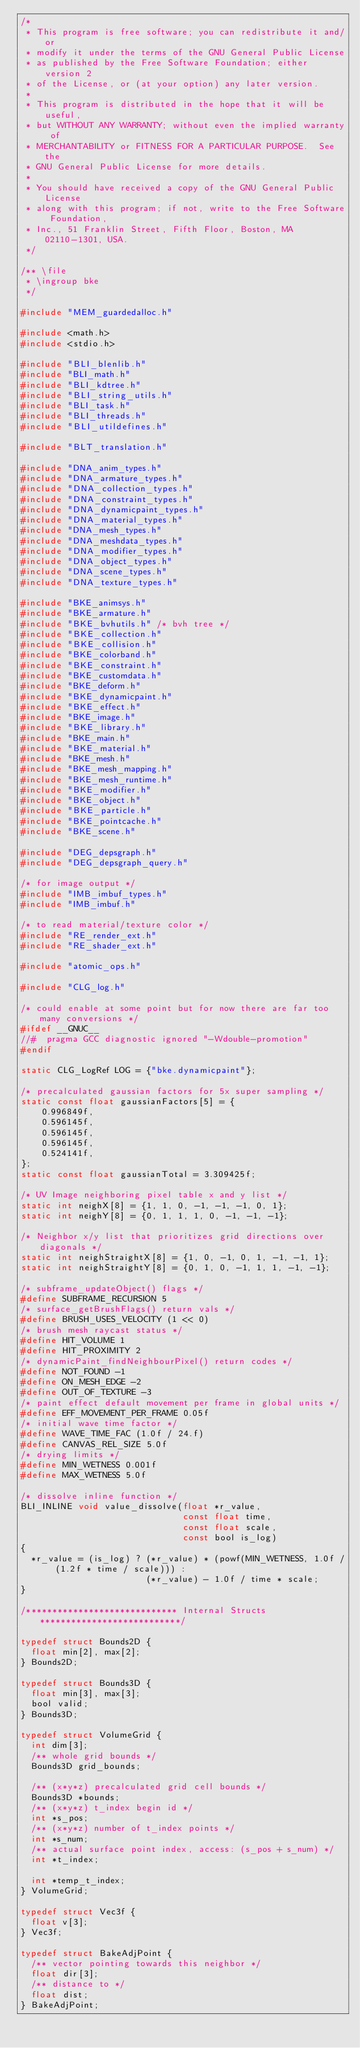<code> <loc_0><loc_0><loc_500><loc_500><_C_>/*
 * This program is free software; you can redistribute it and/or
 * modify it under the terms of the GNU General Public License
 * as published by the Free Software Foundation; either version 2
 * of the License, or (at your option) any later version.
 *
 * This program is distributed in the hope that it will be useful,
 * but WITHOUT ANY WARRANTY; without even the implied warranty of
 * MERCHANTABILITY or FITNESS FOR A PARTICULAR PURPOSE.  See the
 * GNU General Public License for more details.
 *
 * You should have received a copy of the GNU General Public License
 * along with this program; if not, write to the Free Software Foundation,
 * Inc., 51 Franklin Street, Fifth Floor, Boston, MA 02110-1301, USA.
 */

/** \file
 * \ingroup bke
 */

#include "MEM_guardedalloc.h"

#include <math.h>
#include <stdio.h>

#include "BLI_blenlib.h"
#include "BLI_math.h"
#include "BLI_kdtree.h"
#include "BLI_string_utils.h"
#include "BLI_task.h"
#include "BLI_threads.h"
#include "BLI_utildefines.h"

#include "BLT_translation.h"

#include "DNA_anim_types.h"
#include "DNA_armature_types.h"
#include "DNA_collection_types.h"
#include "DNA_constraint_types.h"
#include "DNA_dynamicpaint_types.h"
#include "DNA_material_types.h"
#include "DNA_mesh_types.h"
#include "DNA_meshdata_types.h"
#include "DNA_modifier_types.h"
#include "DNA_object_types.h"
#include "DNA_scene_types.h"
#include "DNA_texture_types.h"

#include "BKE_animsys.h"
#include "BKE_armature.h"
#include "BKE_bvhutils.h" /* bvh tree */
#include "BKE_collection.h"
#include "BKE_collision.h"
#include "BKE_colorband.h"
#include "BKE_constraint.h"
#include "BKE_customdata.h"
#include "BKE_deform.h"
#include "BKE_dynamicpaint.h"
#include "BKE_effect.h"
#include "BKE_image.h"
#include "BKE_library.h"
#include "BKE_main.h"
#include "BKE_material.h"
#include "BKE_mesh.h"
#include "BKE_mesh_mapping.h"
#include "BKE_mesh_runtime.h"
#include "BKE_modifier.h"
#include "BKE_object.h"
#include "BKE_particle.h"
#include "BKE_pointcache.h"
#include "BKE_scene.h"

#include "DEG_depsgraph.h"
#include "DEG_depsgraph_query.h"

/* for image output */
#include "IMB_imbuf_types.h"
#include "IMB_imbuf.h"

/* to read material/texture color */
#include "RE_render_ext.h"
#include "RE_shader_ext.h"

#include "atomic_ops.h"

#include "CLG_log.h"

/* could enable at some point but for now there are far too many conversions */
#ifdef __GNUC__
//#  pragma GCC diagnostic ignored "-Wdouble-promotion"
#endif

static CLG_LogRef LOG = {"bke.dynamicpaint"};

/* precalculated gaussian factors for 5x super sampling */
static const float gaussianFactors[5] = {
    0.996849f,
    0.596145f,
    0.596145f,
    0.596145f,
    0.524141f,
};
static const float gaussianTotal = 3.309425f;

/* UV Image neighboring pixel table x and y list */
static int neighX[8] = {1, 1, 0, -1, -1, -1, 0, 1};
static int neighY[8] = {0, 1, 1, 1, 0, -1, -1, -1};

/* Neighbor x/y list that prioritizes grid directions over diagonals */
static int neighStraightX[8] = {1, 0, -1, 0, 1, -1, -1, 1};
static int neighStraightY[8] = {0, 1, 0, -1, 1, 1, -1, -1};

/* subframe_updateObject() flags */
#define SUBFRAME_RECURSION 5
/* surface_getBrushFlags() return vals */
#define BRUSH_USES_VELOCITY (1 << 0)
/* brush mesh raycast status */
#define HIT_VOLUME 1
#define HIT_PROXIMITY 2
/* dynamicPaint_findNeighbourPixel() return codes */
#define NOT_FOUND -1
#define ON_MESH_EDGE -2
#define OUT_OF_TEXTURE -3
/* paint effect default movement per frame in global units */
#define EFF_MOVEMENT_PER_FRAME 0.05f
/* initial wave time factor */
#define WAVE_TIME_FAC (1.0f / 24.f)
#define CANVAS_REL_SIZE 5.0f
/* drying limits */
#define MIN_WETNESS 0.001f
#define MAX_WETNESS 5.0f

/* dissolve inline function */
BLI_INLINE void value_dissolve(float *r_value,
                               const float time,
                               const float scale,
                               const bool is_log)
{
  *r_value = (is_log) ? (*r_value) * (powf(MIN_WETNESS, 1.0f / (1.2f * time / scale))) :
                        (*r_value) - 1.0f / time * scale;
}

/***************************** Internal Structs ***************************/

typedef struct Bounds2D {
  float min[2], max[2];
} Bounds2D;

typedef struct Bounds3D {
  float min[3], max[3];
  bool valid;
} Bounds3D;

typedef struct VolumeGrid {
  int dim[3];
  /** whole grid bounds */
  Bounds3D grid_bounds;

  /** (x*y*z) precalculated grid cell bounds */
  Bounds3D *bounds;
  /** (x*y*z) t_index begin id */
  int *s_pos;
  /** (x*y*z) number of t_index points */
  int *s_num;
  /** actual surface point index, access: (s_pos + s_num) */
  int *t_index;

  int *temp_t_index;
} VolumeGrid;

typedef struct Vec3f {
  float v[3];
} Vec3f;

typedef struct BakeAdjPoint {
  /** vector pointing towards this neighbor */
  float dir[3];
  /** distance to */
  float dist;
} BakeAdjPoint;
</code> 